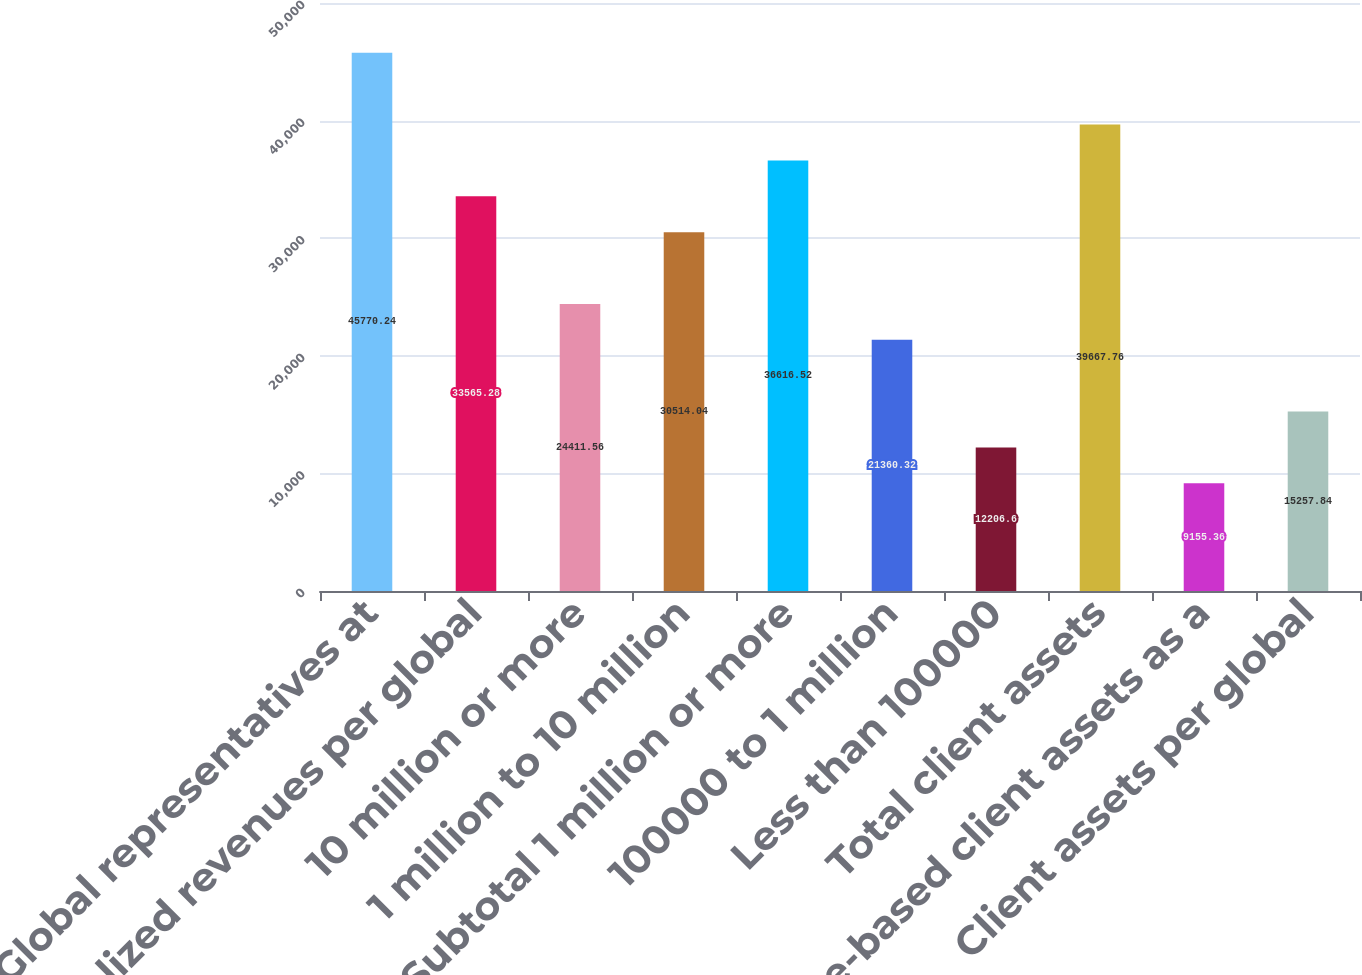<chart> <loc_0><loc_0><loc_500><loc_500><bar_chart><fcel>Global representatives at<fcel>Annualized revenues per global<fcel>10 million or more<fcel>1 million to 10 million<fcel>Subtotal 1 million or more<fcel>100000 to 1 million<fcel>Less than 100000<fcel>Total client assets<fcel>Fee-based client assets as a<fcel>Client assets per global<nl><fcel>45770.2<fcel>33565.3<fcel>24411.6<fcel>30514<fcel>36616.5<fcel>21360.3<fcel>12206.6<fcel>39667.8<fcel>9155.36<fcel>15257.8<nl></chart> 